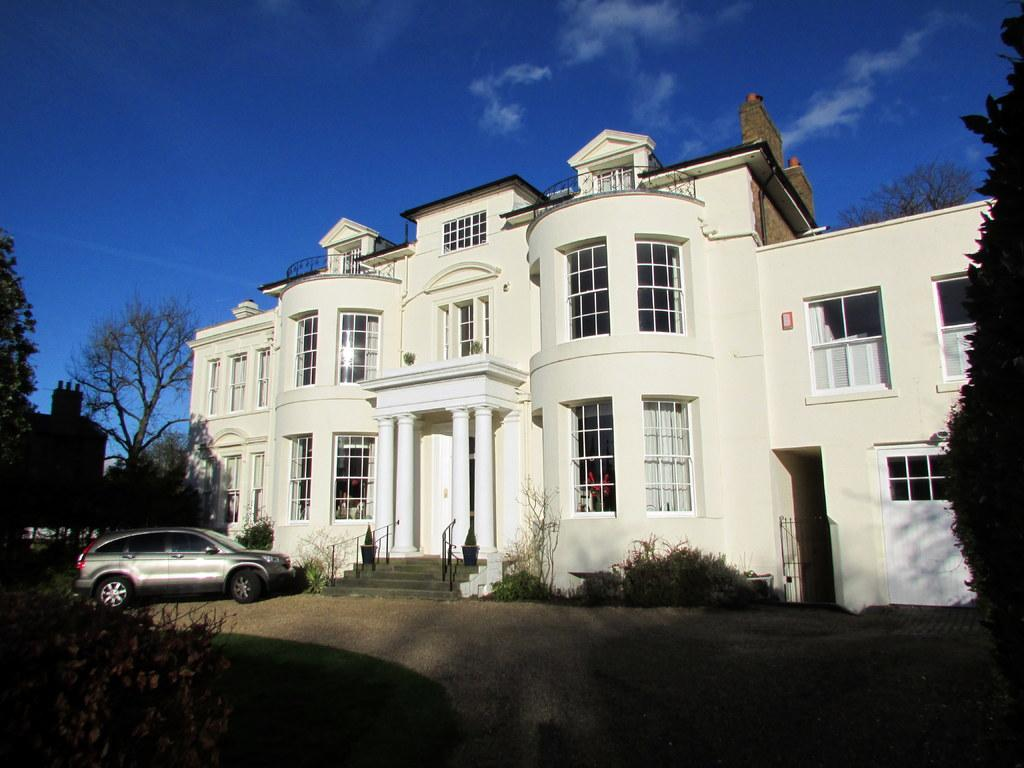What type of structure is visible in the image? There is a building in the image. What is parked in front of the building? There is a car in front of the building. What type of vegetation can be seen in the image? There are trees and plants in the image. What is visible at the top of the image? The sky is visible at the top of the image. What type of joke is being told by the building in the image? There is no joke being told by the building in the image; it is a stationary structure. What type of card is being used to expand the building in the image? There is no card or expansion being depicted in the image; it shows a building, a car, trees, plants, and the sky. 